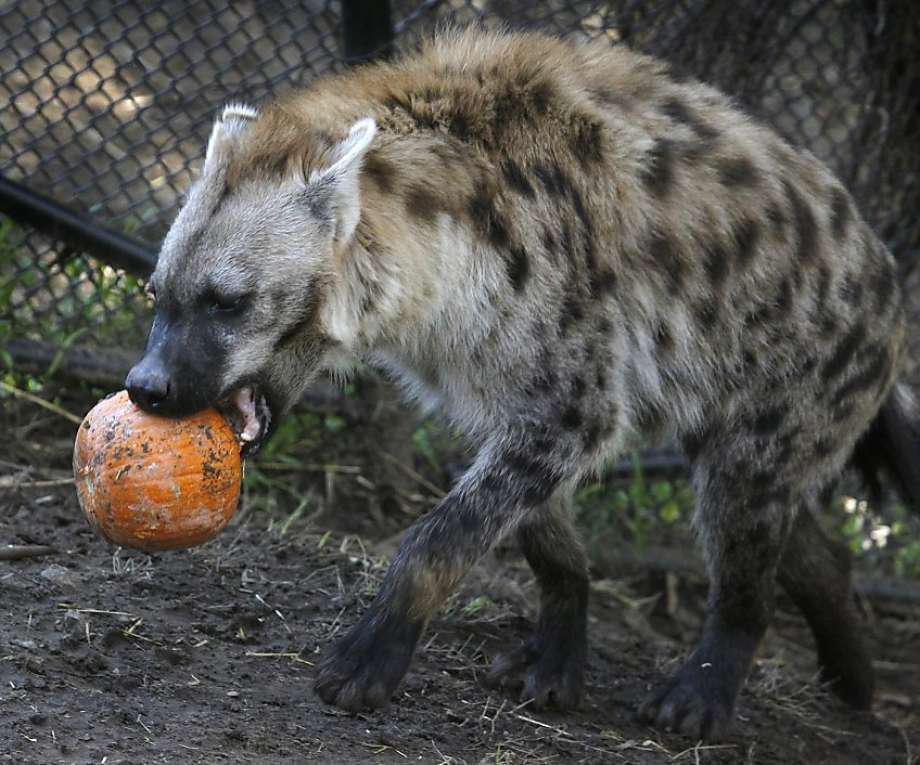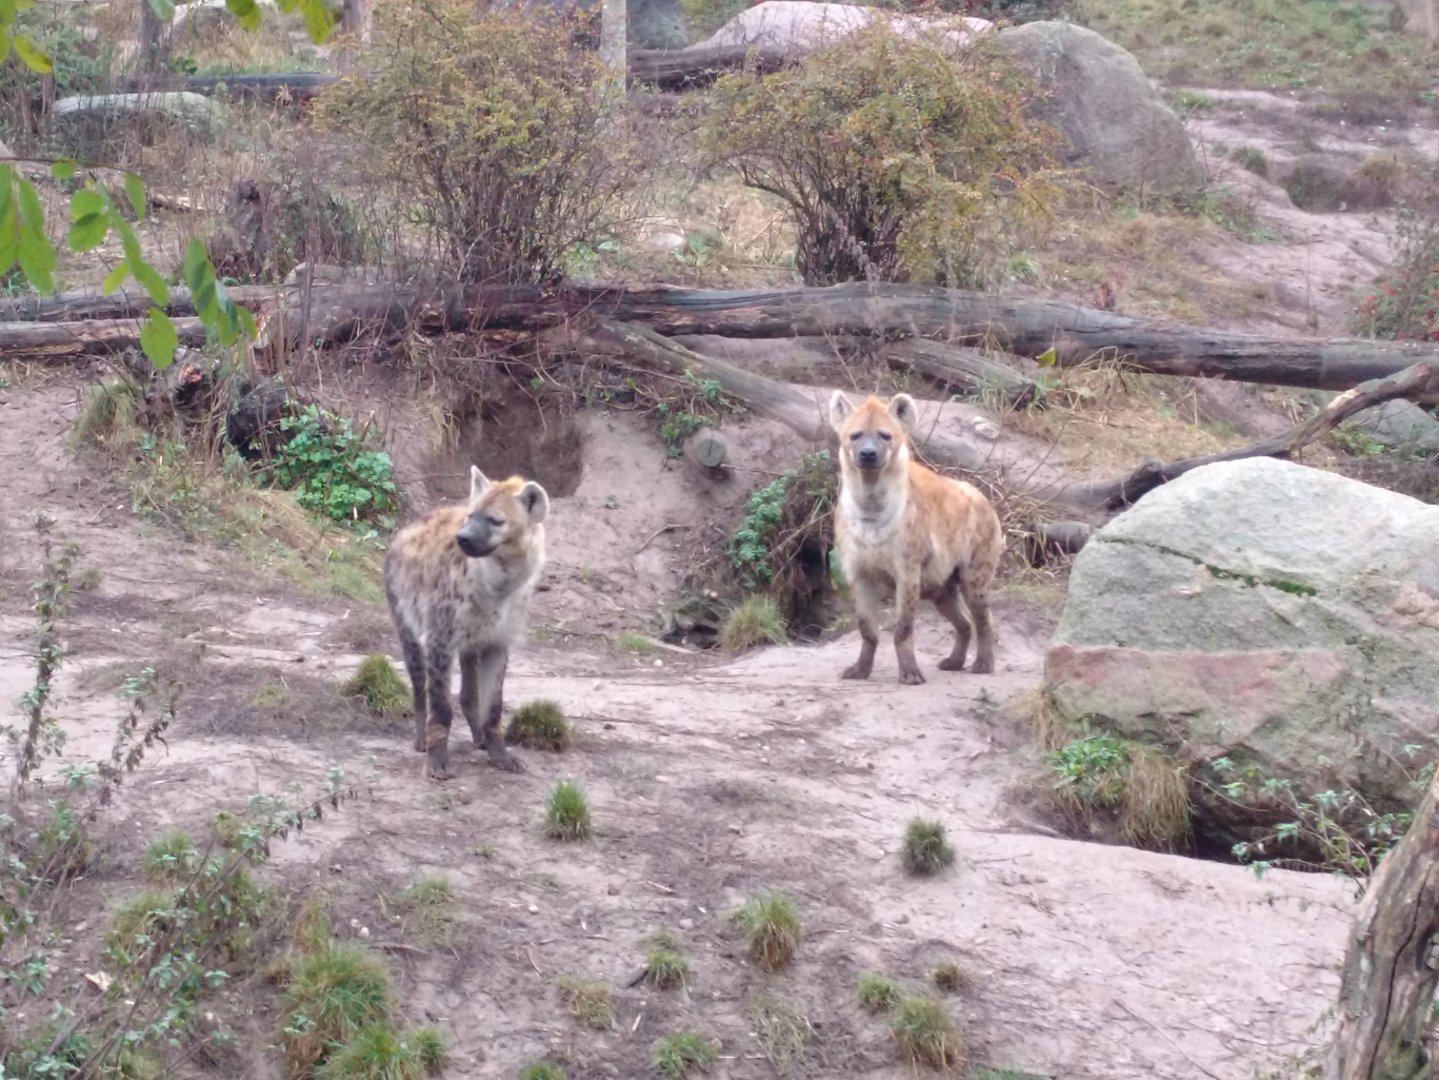The first image is the image on the left, the second image is the image on the right. Assess this claim about the two images: "A hyena is carrying something in its mouth.". Correct or not? Answer yes or no. Yes. The first image is the image on the left, the second image is the image on the right. Analyze the images presented: Is the assertion "At least one hyena has its legs in water." valid? Answer yes or no. No. 